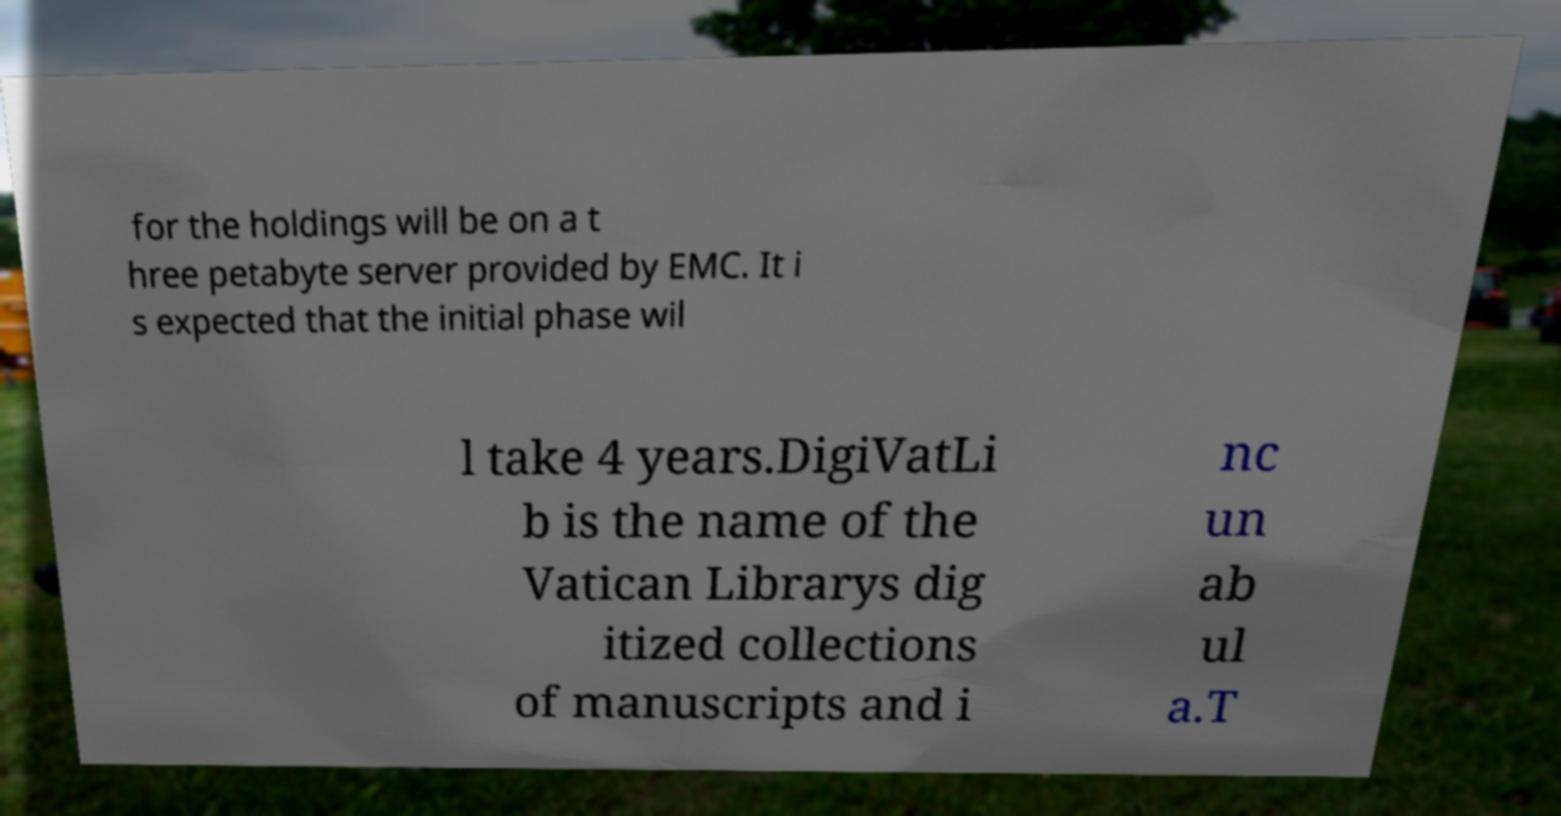I need the written content from this picture converted into text. Can you do that? for the holdings will be on a t hree petabyte server provided by EMC. It i s expected that the initial phase wil l take 4 years.DigiVatLi b is the name of the Vatican Librarys dig itized collections of manuscripts and i nc un ab ul a.T 